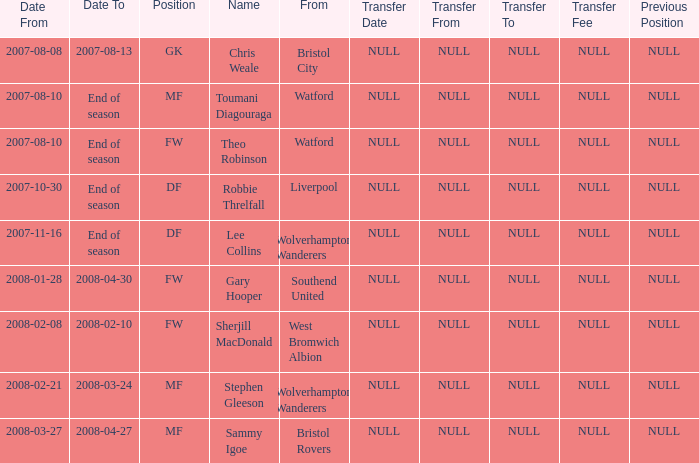What was the from for the Date From of 2007-08-08? Bristol City. 